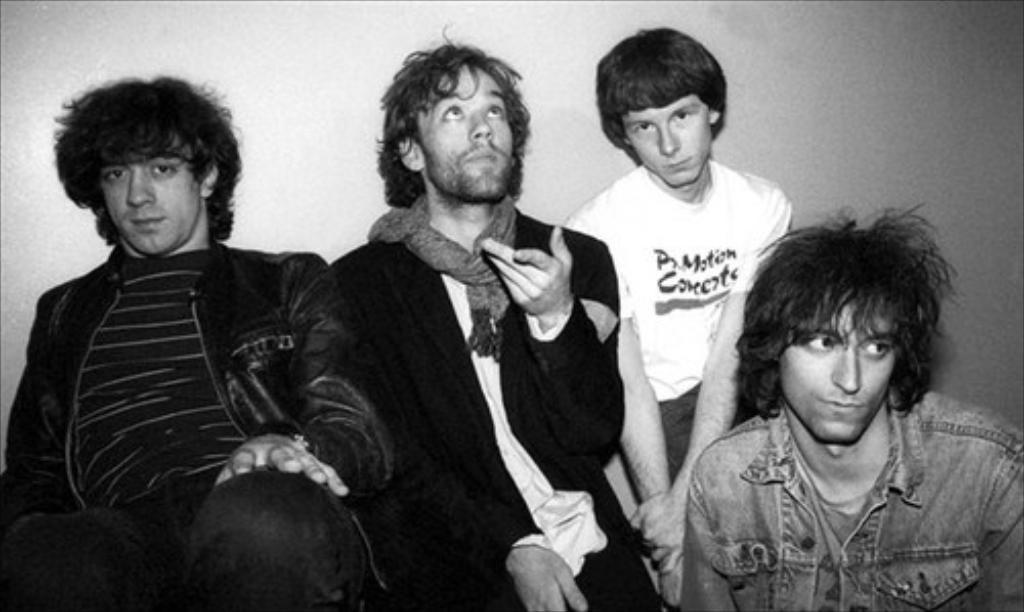Could you give a brief overview of what you see in this image? This is black and white picture,there are people. In the background we can see wall. 